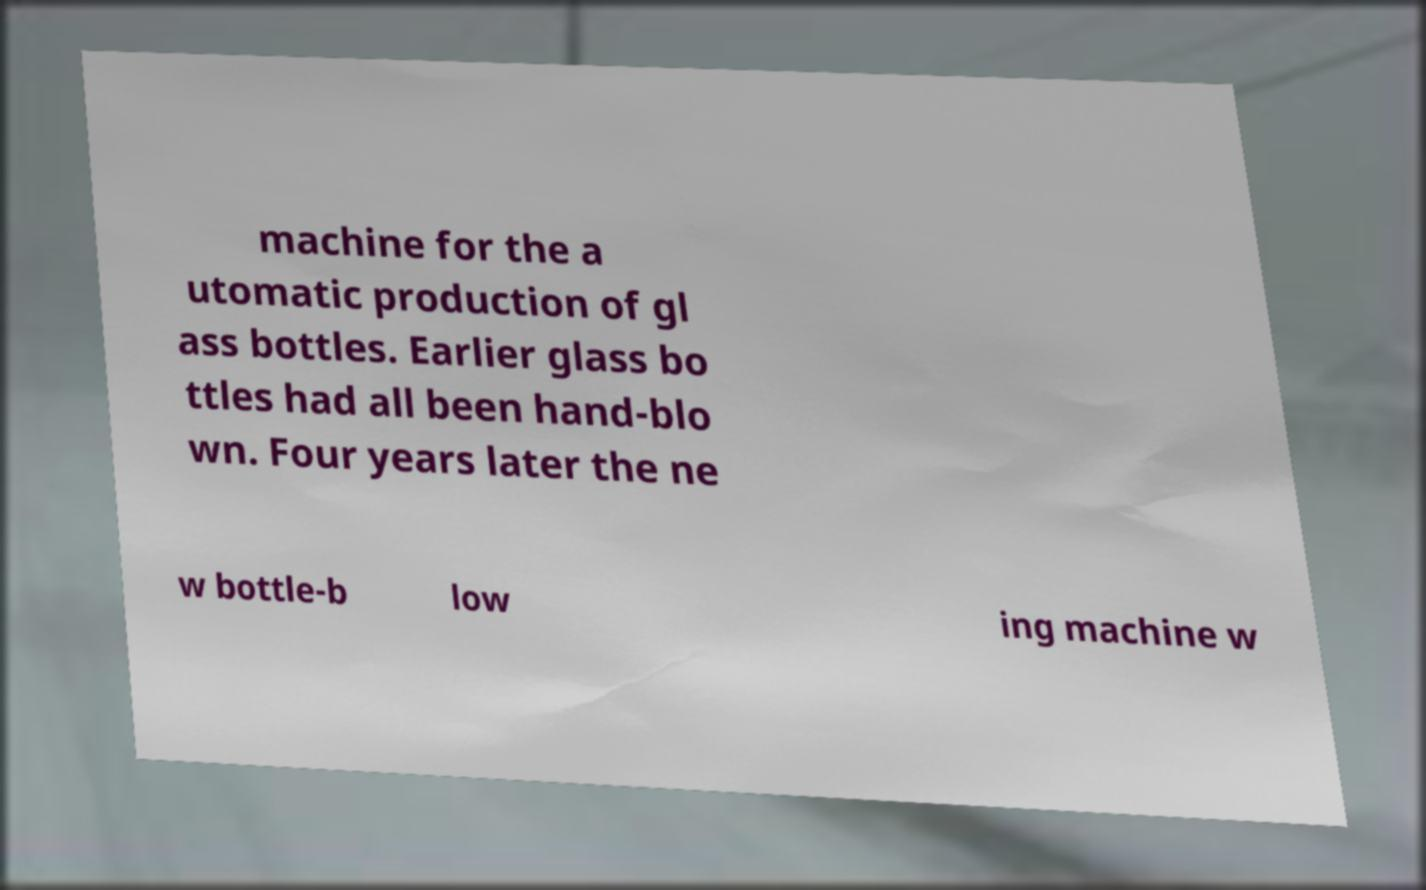There's text embedded in this image that I need extracted. Can you transcribe it verbatim? machine for the a utomatic production of gl ass bottles. Earlier glass bo ttles had all been hand-blo wn. Four years later the ne w bottle-b low ing machine w 